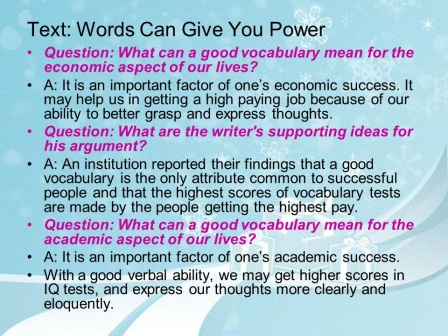Imagine a futuristic scenario where vocabulary dictates one's social status. Describe how the world functions. In a futuristic society where vocabulary dictates social status, words carry immense power. Citizens are ranked based on their mastery of language, with an advanced dialect known as 'Lexicon Prime' cherished by the elite. Education systems focus heavily on linguistic training, and public speaking events are the ultimate social gatherings. People's statuses are identified by digital badges reflecting their vocabulary level, unlocking special privileges in society such as access to exclusive clubs, premium healthcare, and influential networks. Daily interactions, business transactions, and even dating revolve around verbal prowess. Automated systems monitor conversations, offering real-time analyses of linguistic performance, contributing to one's 'Lex Score'. Success stories often feature individuals from modest backgrounds who excelled in language academies. Politicians and leaders are chosen through grand rhetoric tournaments, where their ability to inspire through words becomes the measure of their potential to lead. In this world, words not only create but can also transform and redefine destinies, making vocabulary the ultimate currency. 